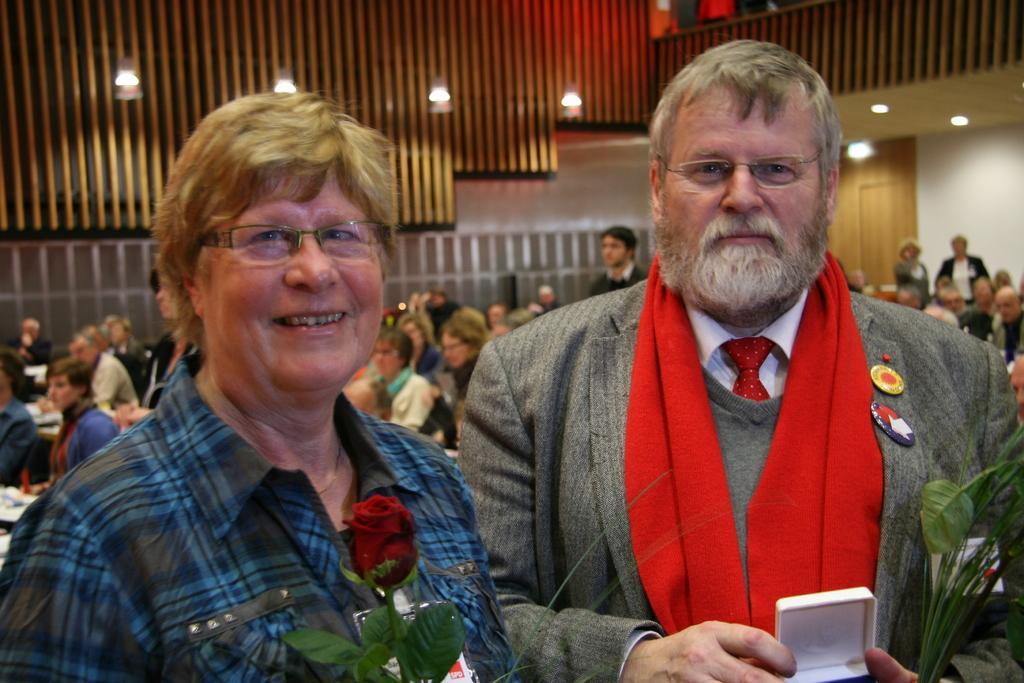How would you summarize this image in a sentence or two? In this image I can see a woman wearing blue and black colored dress and a man wearing red, grey and white colored dress are standing and holding few objects in their hands. In the background I can see number of persons are sitting, few persons standing, the walls and few lights. 